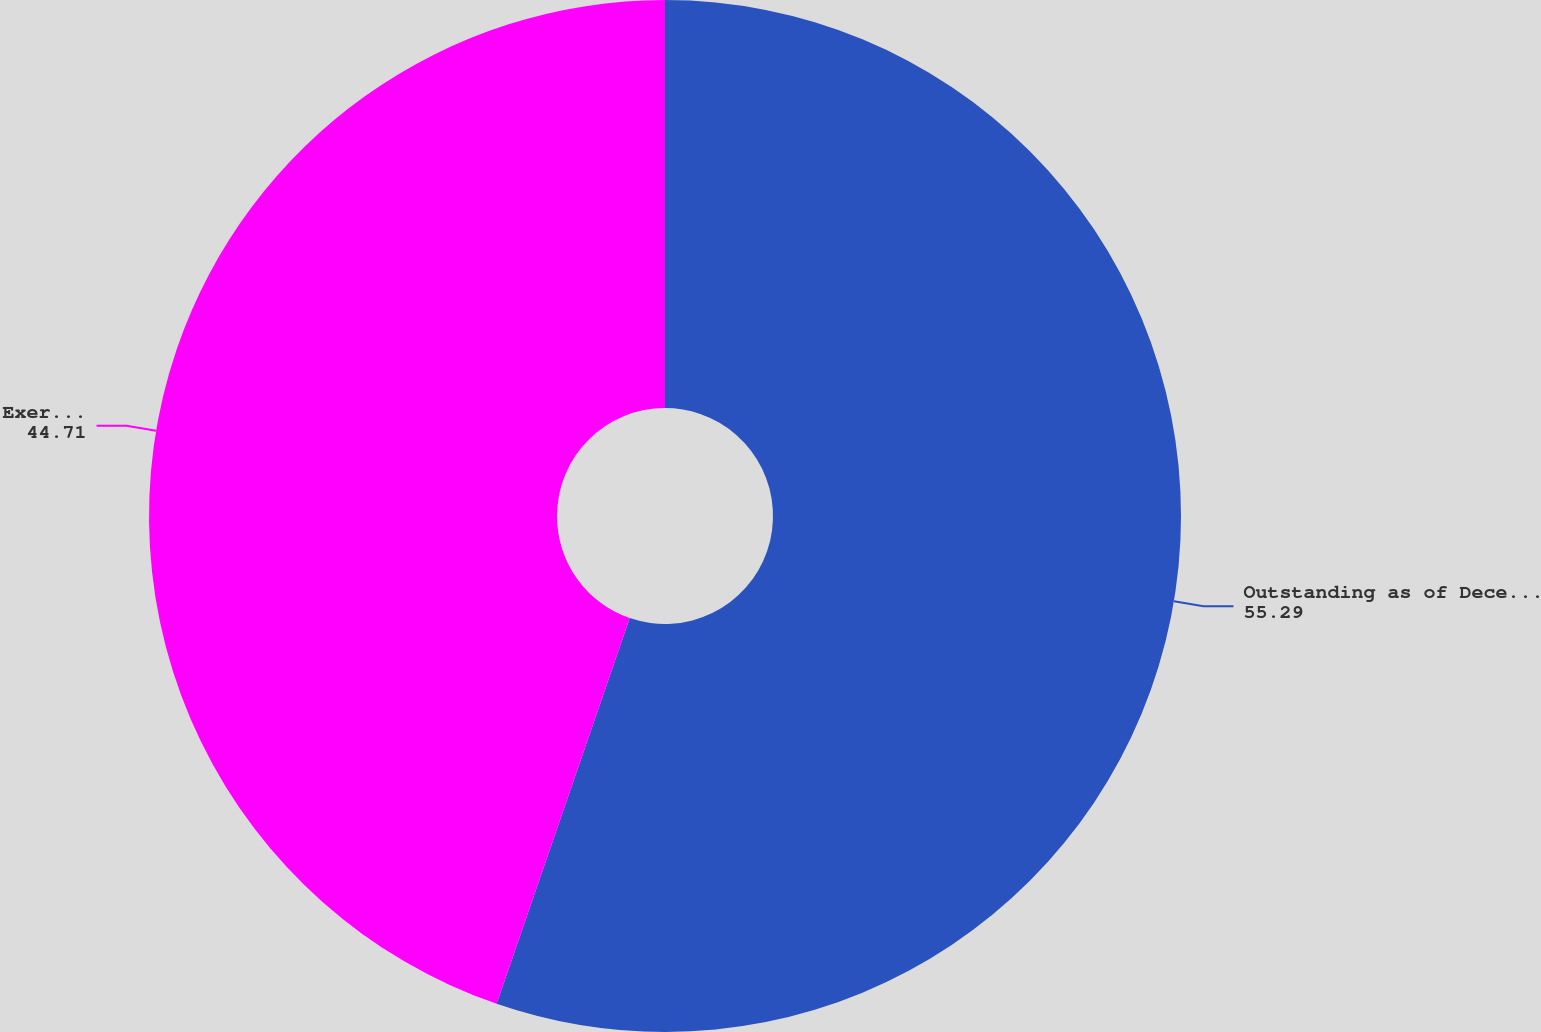Convert chart to OTSL. <chart><loc_0><loc_0><loc_500><loc_500><pie_chart><fcel>Outstanding as of December 31<fcel>Exercisable as of December 31<nl><fcel>55.29%<fcel>44.71%<nl></chart> 